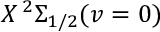<formula> <loc_0><loc_0><loc_500><loc_500>X \, ^ { 2 } \Sigma _ { 1 / 2 } ( v = 0 )</formula> 